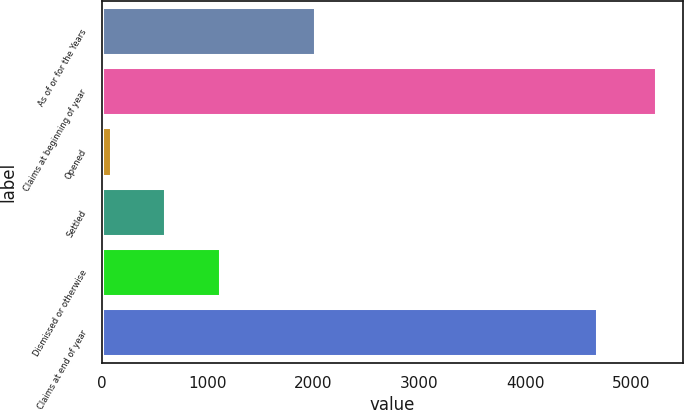Convert chart. <chart><loc_0><loc_0><loc_500><loc_500><bar_chart><fcel>As of or for the Years<fcel>Claims at beginning of year<fcel>Opened<fcel>Settled<fcel>Dismissed or otherwise<fcel>Claims at end of year<nl><fcel>2013<fcel>5230<fcel>83<fcel>597.7<fcel>1112.4<fcel>4680<nl></chart> 